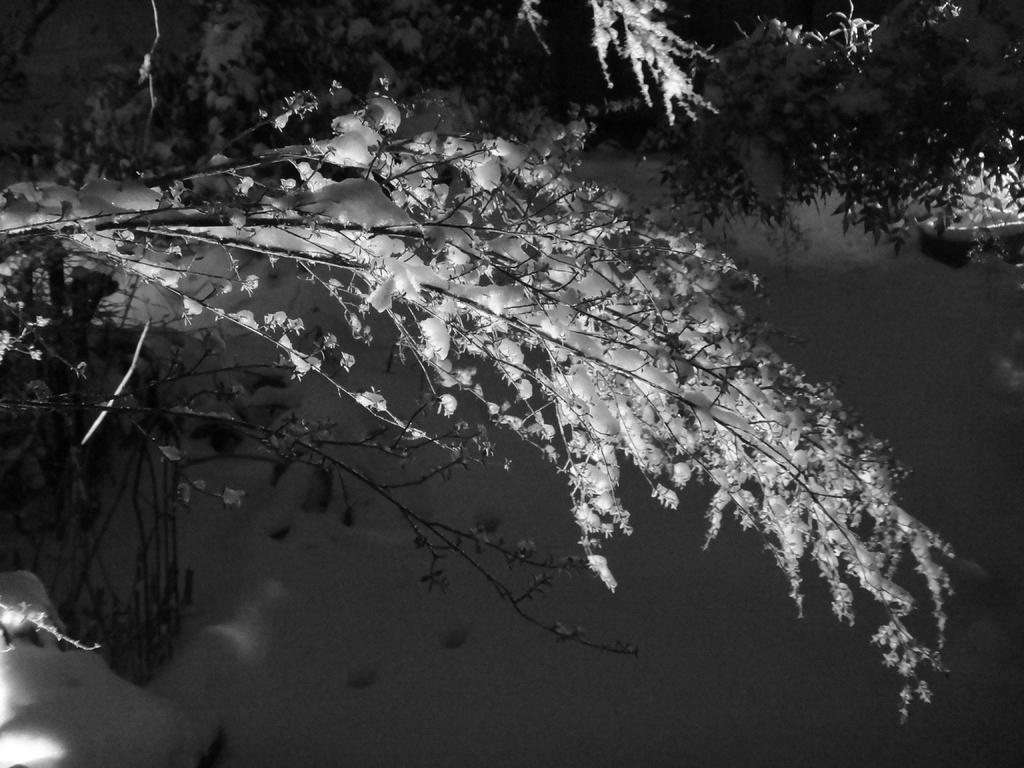What type of natural elements can be seen in the image? There are trees in the image. What part of the natural environment is visible in the image? The sky is visible in the background of the image. What is the color scheme of the image? The image is in black and white. Where is the lunchroom located in the image? There is no lunchroom present in the image. What type of transportation can be seen in the image? There are no trains or any other form of transportation present in the image. 